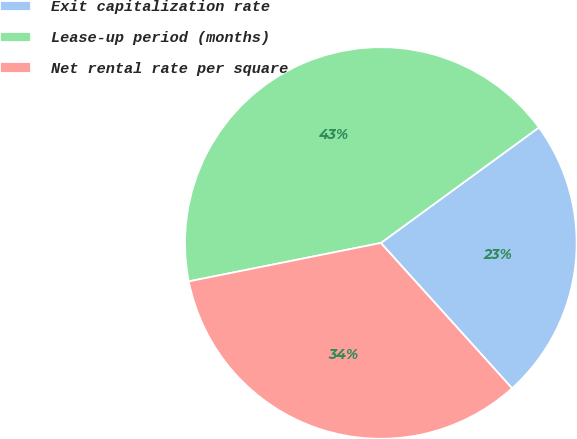Convert chart. <chart><loc_0><loc_0><loc_500><loc_500><pie_chart><fcel>Exit capitalization rate<fcel>Lease-up period (months)<fcel>Net rental rate per square<nl><fcel>23.35%<fcel>43.1%<fcel>33.55%<nl></chart> 